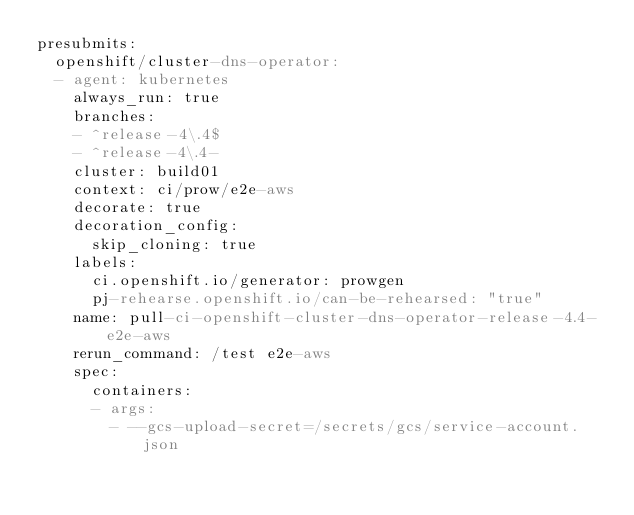Convert code to text. <code><loc_0><loc_0><loc_500><loc_500><_YAML_>presubmits:
  openshift/cluster-dns-operator:
  - agent: kubernetes
    always_run: true
    branches:
    - ^release-4\.4$
    - ^release-4\.4-
    cluster: build01
    context: ci/prow/e2e-aws
    decorate: true
    decoration_config:
      skip_cloning: true
    labels:
      ci.openshift.io/generator: prowgen
      pj-rehearse.openshift.io/can-be-rehearsed: "true"
    name: pull-ci-openshift-cluster-dns-operator-release-4.4-e2e-aws
    rerun_command: /test e2e-aws
    spec:
      containers:
      - args:
        - --gcs-upload-secret=/secrets/gcs/service-account.json</code> 